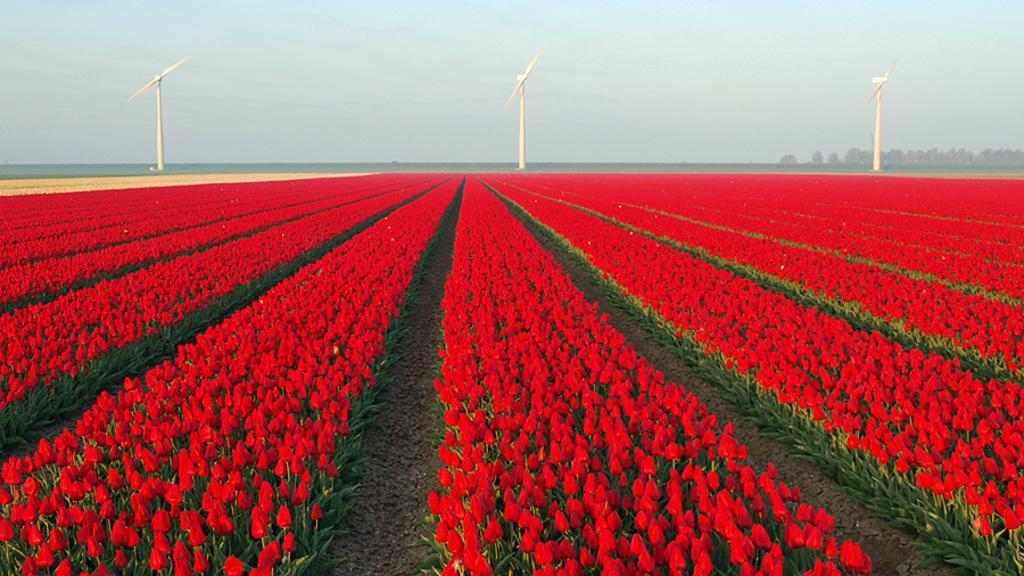Can you describe this image briefly? In this image we can see a flower garden. There are windmills in the image. There are many trees in the image. 